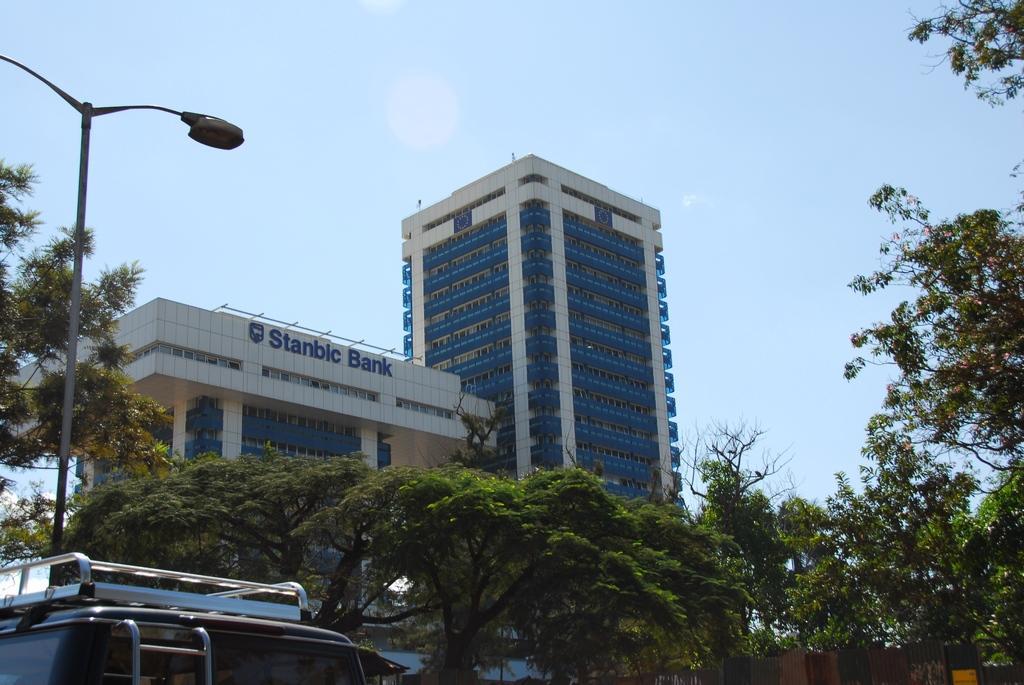In one or two sentences, can you explain what this image depicts? There is a vehicle in the left corner and there are trees and a building in the background. 